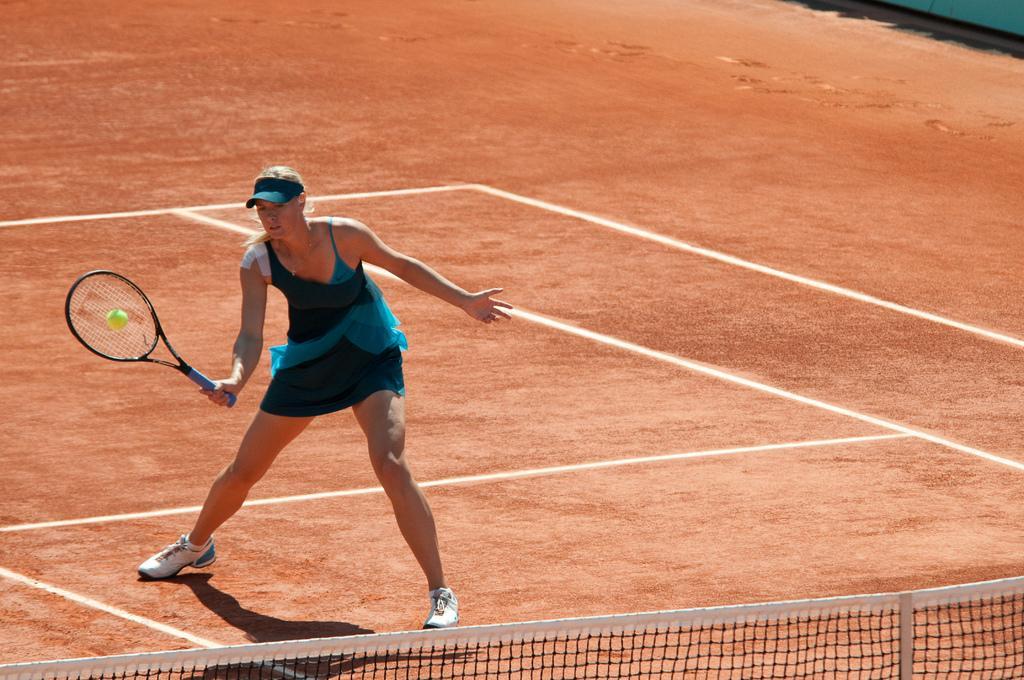In one or two sentences, can you explain what this image depicts? In this image I can see a person wearing a skirt and cap playing a game on the ground at the bottom I can see fence and the woman holding a bat and I can see a ball. 